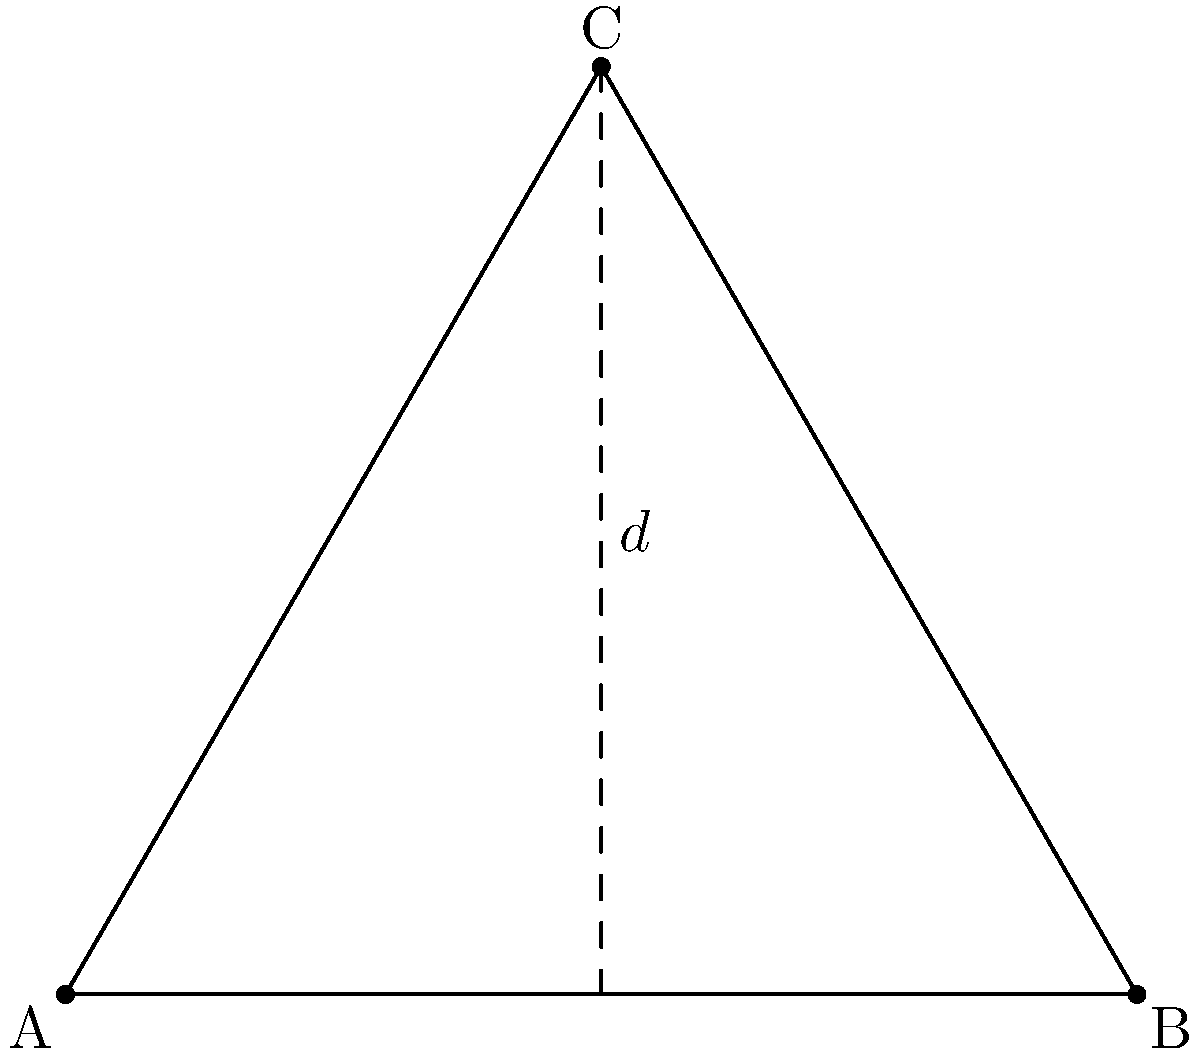In a sacred geometry design, an equilateral triangle ABC is drawn with side length 5 units. Point M is the midpoint of side AB. Calculate the length of the line segment CM, which represents the height of the triangle, to determine the golden ratio proportion in the design. To solve this problem, we'll follow these steps:

1) In an equilateral triangle, the height (h) from any vertex to the opposite side bisects that side. So, CM is the height of the triangle.

2) We can use the Pythagorean theorem to find the height. Let's call the half of the side length x:

   $x = \frac{5}{2} = 2.5$

3) Now we can set up the Pythagorean theorem:

   $h^2 + x^2 = 5^2$

4) Substitute the known values:

   $h^2 + 2.5^2 = 5^2$

5) Simplify:

   $h^2 + 6.25 = 25$

6) Solve for h:

   $h^2 = 18.75$
   $h = \sqrt{18.75} = \frac{\sqrt{75}}{2}$

7) Simplify the square root:

   $h = \frac{\sqrt{25 \cdot 3}}{2} = \frac{5\sqrt{3}}{2}$

8) Calculate the numeric value:

   $h \approx 4.33$ units

This height (4.33) to half-side (2.5) ratio is very close to the golden ratio (≈1.618), which is often used in sacred geometry.
Answer: $\frac{5\sqrt{3}}{2}$ units (or approximately 4.33 units) 